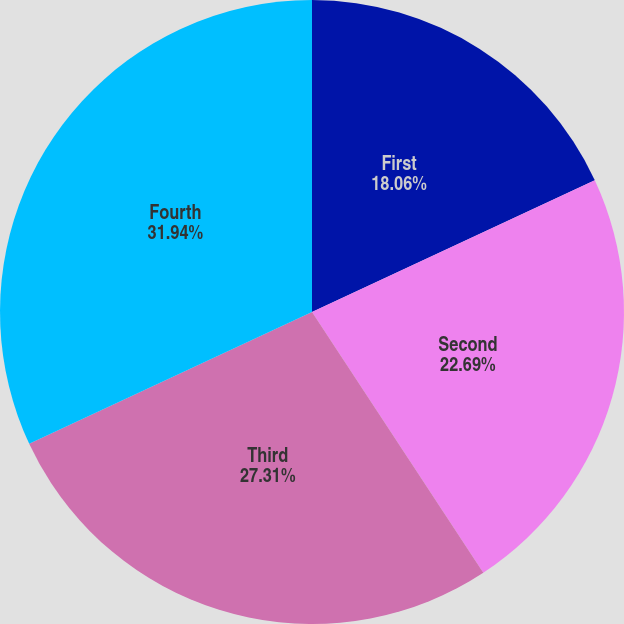Convert chart to OTSL. <chart><loc_0><loc_0><loc_500><loc_500><pie_chart><fcel>First<fcel>Second<fcel>Third<fcel>Fourth<nl><fcel>18.06%<fcel>22.69%<fcel>27.31%<fcel>31.94%<nl></chart> 